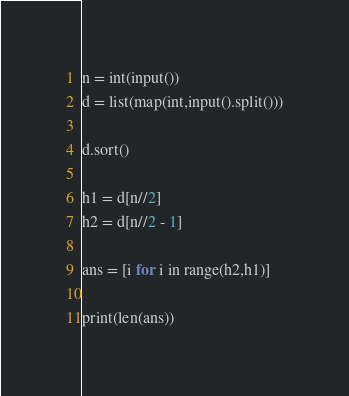<code> <loc_0><loc_0><loc_500><loc_500><_Python_>n = int(input())
d = list(map(int,input().split()))

d.sort()

h1 = d[n//2]
h2 = d[n//2 - 1]

ans = [i for i in range(h2,h1)]

print(len(ans))</code> 